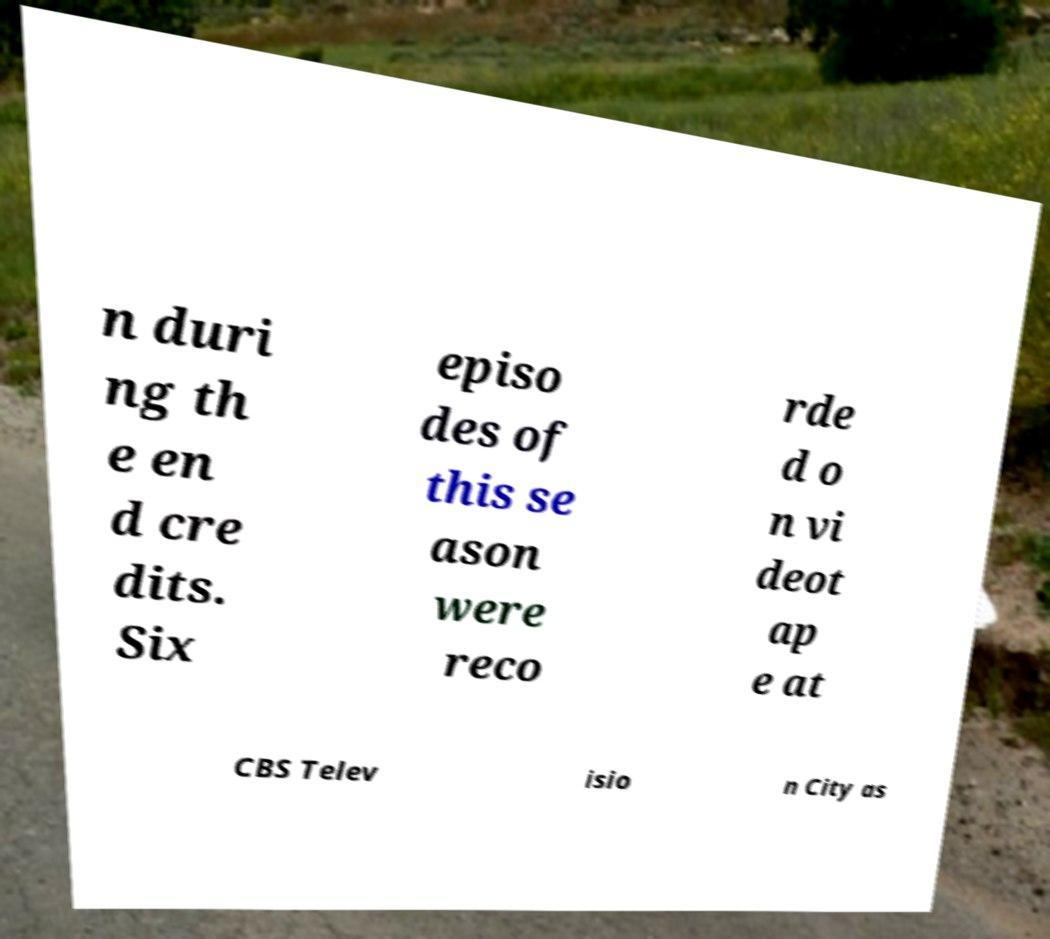Can you read and provide the text displayed in the image?This photo seems to have some interesting text. Can you extract and type it out for me? n duri ng th e en d cre dits. Six episo des of this se ason were reco rde d o n vi deot ap e at CBS Telev isio n City as 